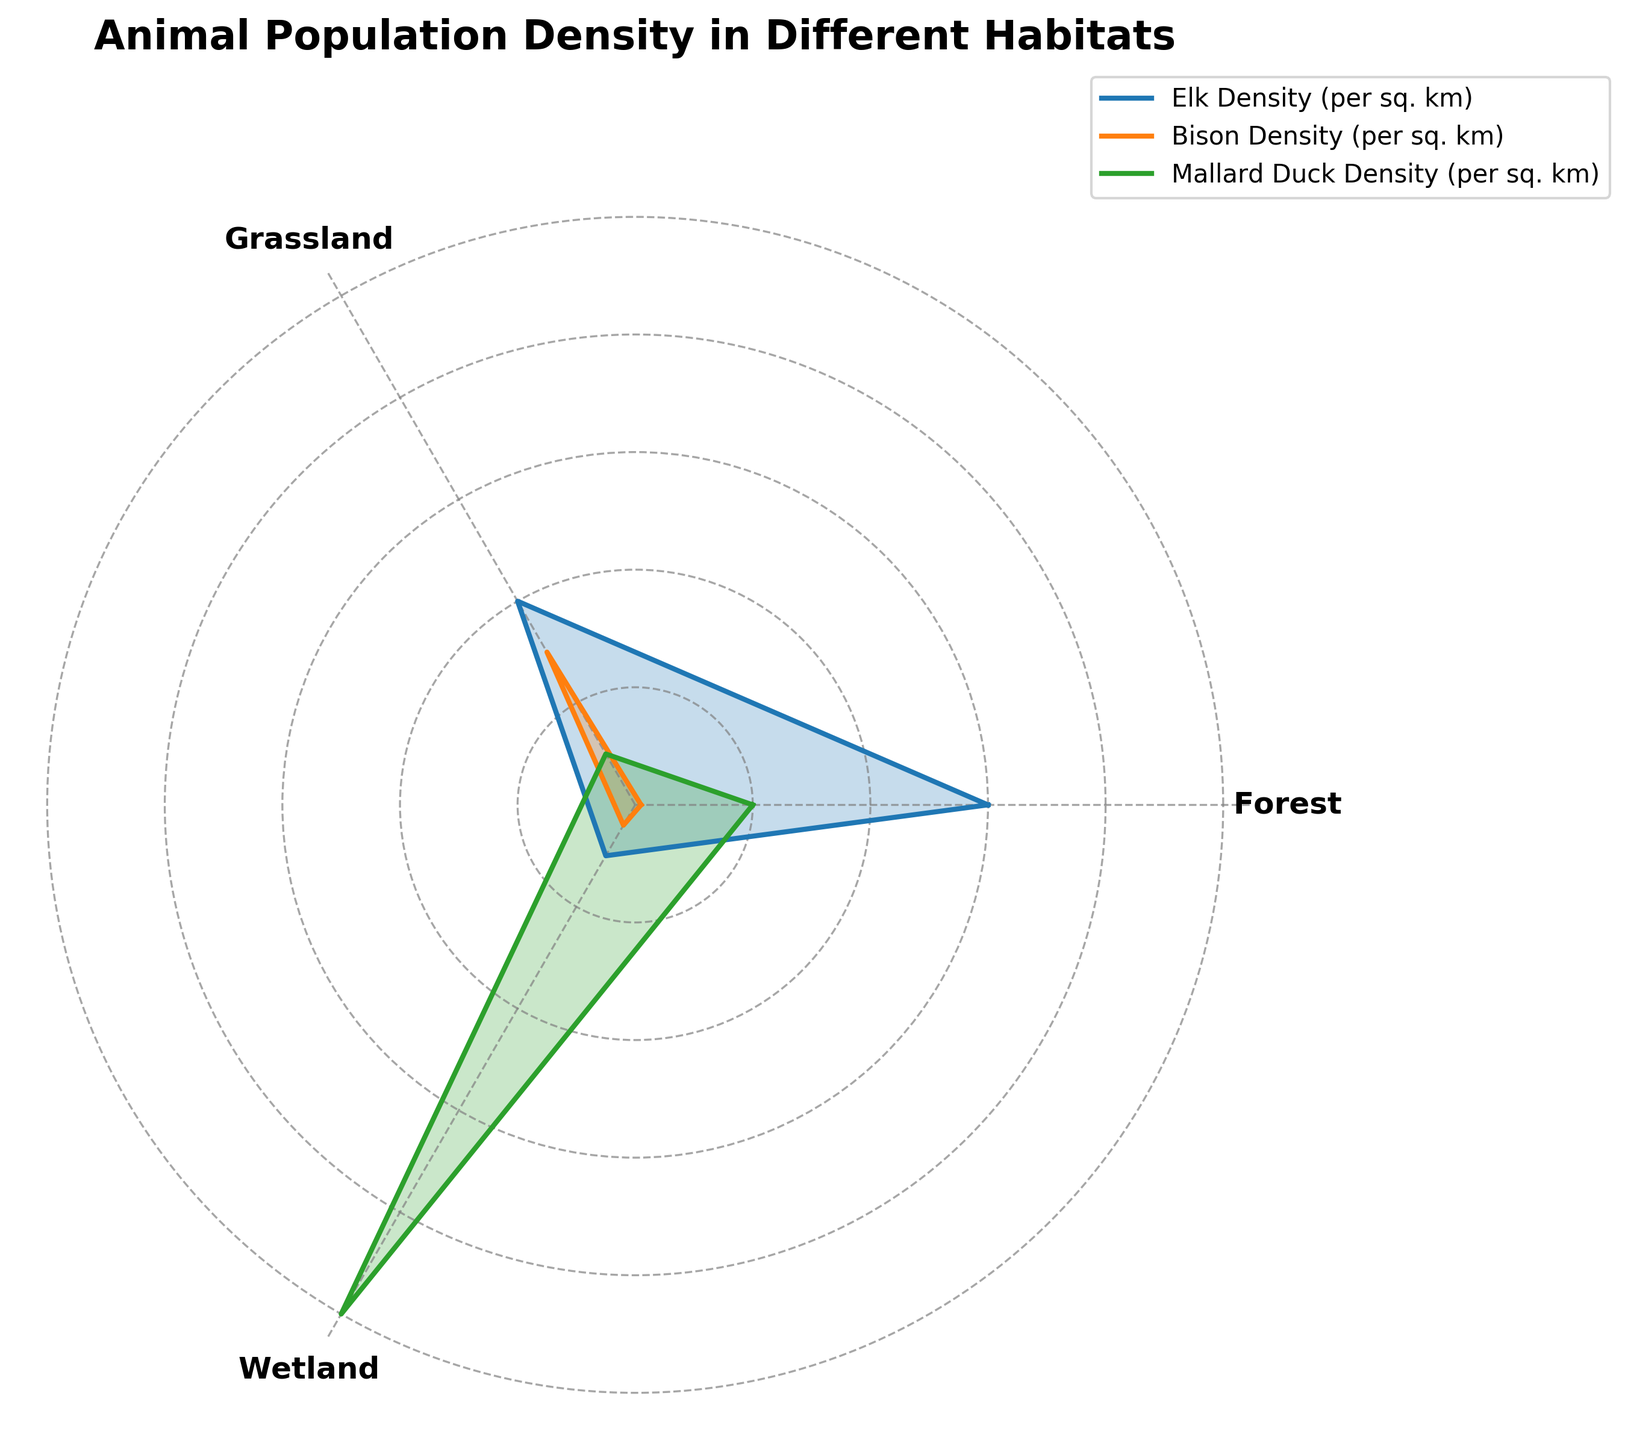What is the title of the radar chart? Look at the title displayed at the top of the radar chart. It describes the subject of the visualization, stating "Animal Population Density in Different Habitats".
Answer: Animal Population Density in Different Habitats Which animal has the highest density in Wetland areas? Identify the values for each animal in the Wetland category. The Mallard Duck has the highest value at 50.
Answer: Mallard Duck Which habitat has the lowest Elk Density? Examine the values for Elk Density across different habitats. The Wetland habitat has the lowest value at 5.
Answer: Wetland What is the average Bison Density across all habitat types? Calculate the average by summing the Bison Densities for all habitats (0.5 + 15 + 2) and then dividing by the number of habitats (3). The sum is 17.5, and the average is 17.5 / 3 = 5.83.
Answer: 5.83 In which habitat is the difference between Bison and Elk Density the greatest? Determine the differences for each habitat: Forest (30 - 0.5 = 29.5), Grassland (20 - 15 = 5), Wetland (5 - 2 = 3). The Forest habitat has the greatest difference of 29.5.
Answer: Forest Which animal shows the most variation in population density across different habitats? Compare the spread of values for each animal across all habitats. The Mallard Duck ranges from 5 to 50, showing the highest variation.
Answer: Mallard Duck Is the Bison Density greater in Grassland or Wetland? Compare the Bison Density values in Grassland (15) and Wetland (2). Bison Density is greater in Grassland.
Answer: Grassland What is the total Mallard Duck Density across all habitats? Sum the Mallard Duck Density values for all habitats (10 + 5 + 50) to get a total of 65.
Answer: 65 Between Elk and Mallard Ducks, which animal has a higher density in Forest, and by how much? Compare their density values in Forest (Elk: 30, Mallard Duck: 10). Elk density is higher by a difference of 20 (30 - 10).
Answer: Elk by 20 Which habitat type has the highest overall animal density combined if we sum densities of all three animals? Calculate the combined sum for each habitat: Forest (30 + 0.5 + 10 = 40.5), Grassland (20 + 15 + 5 = 40), Wetland (5 + 2 + 50 = 57). Wetland has the highest combined density of 57.
Answer: Wetland 